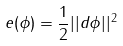<formula> <loc_0><loc_0><loc_500><loc_500>e ( \phi ) = \frac { 1 } { 2 } | | d \phi | | ^ { 2 }</formula> 